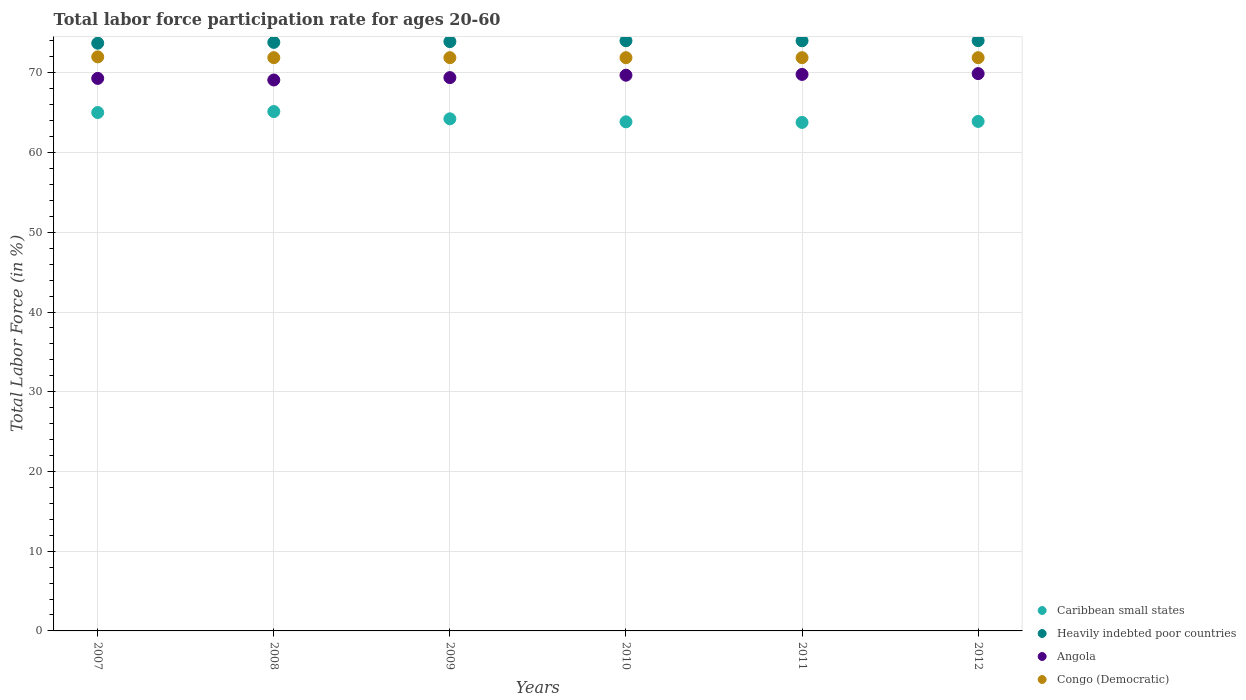How many different coloured dotlines are there?
Keep it short and to the point. 4. Is the number of dotlines equal to the number of legend labels?
Give a very brief answer. Yes. What is the labor force participation rate in Congo (Democratic) in 2011?
Provide a short and direct response. 71.9. Across all years, what is the maximum labor force participation rate in Heavily indebted poor countries?
Give a very brief answer. 74.03. Across all years, what is the minimum labor force participation rate in Congo (Democratic)?
Your response must be concise. 71.9. In which year was the labor force participation rate in Heavily indebted poor countries maximum?
Your response must be concise. 2012. What is the total labor force participation rate in Heavily indebted poor countries in the graph?
Offer a very short reply. 443.52. What is the difference between the labor force participation rate in Heavily indebted poor countries in 2010 and that in 2011?
Provide a short and direct response. 0.01. What is the difference between the labor force participation rate in Heavily indebted poor countries in 2007 and the labor force participation rate in Congo (Democratic) in 2010?
Keep it short and to the point. 1.82. What is the average labor force participation rate in Heavily indebted poor countries per year?
Your response must be concise. 73.92. In the year 2007, what is the difference between the labor force participation rate in Congo (Democratic) and labor force participation rate in Caribbean small states?
Provide a succinct answer. 6.98. What is the ratio of the labor force participation rate in Congo (Democratic) in 2011 to that in 2012?
Give a very brief answer. 1. Is the labor force participation rate in Congo (Democratic) in 2007 less than that in 2008?
Keep it short and to the point. No. What is the difference between the highest and the second highest labor force participation rate in Heavily indebted poor countries?
Offer a very short reply. 0.01. What is the difference between the highest and the lowest labor force participation rate in Heavily indebted poor countries?
Your answer should be compact. 0.32. In how many years, is the labor force participation rate in Caribbean small states greater than the average labor force participation rate in Caribbean small states taken over all years?
Offer a terse response. 2. Is it the case that in every year, the sum of the labor force participation rate in Congo (Democratic) and labor force participation rate in Caribbean small states  is greater than the sum of labor force participation rate in Heavily indebted poor countries and labor force participation rate in Angola?
Your response must be concise. Yes. Is it the case that in every year, the sum of the labor force participation rate in Caribbean small states and labor force participation rate in Heavily indebted poor countries  is greater than the labor force participation rate in Angola?
Keep it short and to the point. Yes. Is the labor force participation rate in Caribbean small states strictly greater than the labor force participation rate in Angola over the years?
Make the answer very short. No. How many years are there in the graph?
Your response must be concise. 6. Are the values on the major ticks of Y-axis written in scientific E-notation?
Keep it short and to the point. No. Does the graph contain any zero values?
Make the answer very short. No. Does the graph contain grids?
Offer a very short reply. Yes. How are the legend labels stacked?
Your answer should be very brief. Vertical. What is the title of the graph?
Offer a terse response. Total labor force participation rate for ages 20-60. Does "Lower middle income" appear as one of the legend labels in the graph?
Your response must be concise. No. What is the Total Labor Force (in %) in Caribbean small states in 2007?
Provide a succinct answer. 65.02. What is the Total Labor Force (in %) in Heavily indebted poor countries in 2007?
Provide a short and direct response. 73.72. What is the Total Labor Force (in %) in Angola in 2007?
Provide a short and direct response. 69.3. What is the Total Labor Force (in %) in Caribbean small states in 2008?
Keep it short and to the point. 65.14. What is the Total Labor Force (in %) of Heavily indebted poor countries in 2008?
Your answer should be compact. 73.82. What is the Total Labor Force (in %) of Angola in 2008?
Your answer should be compact. 69.1. What is the Total Labor Force (in %) of Congo (Democratic) in 2008?
Give a very brief answer. 71.9. What is the Total Labor Force (in %) of Caribbean small states in 2009?
Your response must be concise. 64.23. What is the Total Labor Force (in %) of Heavily indebted poor countries in 2009?
Provide a short and direct response. 73.92. What is the Total Labor Force (in %) in Angola in 2009?
Provide a succinct answer. 69.4. What is the Total Labor Force (in %) of Congo (Democratic) in 2009?
Your answer should be very brief. 71.9. What is the Total Labor Force (in %) of Caribbean small states in 2010?
Provide a short and direct response. 63.85. What is the Total Labor Force (in %) in Heavily indebted poor countries in 2010?
Provide a short and direct response. 74.02. What is the Total Labor Force (in %) of Angola in 2010?
Make the answer very short. 69.7. What is the Total Labor Force (in %) of Congo (Democratic) in 2010?
Provide a short and direct response. 71.9. What is the Total Labor Force (in %) of Caribbean small states in 2011?
Offer a terse response. 63.78. What is the Total Labor Force (in %) of Heavily indebted poor countries in 2011?
Provide a short and direct response. 74.02. What is the Total Labor Force (in %) of Angola in 2011?
Offer a very short reply. 69.8. What is the Total Labor Force (in %) in Congo (Democratic) in 2011?
Provide a succinct answer. 71.9. What is the Total Labor Force (in %) of Caribbean small states in 2012?
Your response must be concise. 63.9. What is the Total Labor Force (in %) of Heavily indebted poor countries in 2012?
Your answer should be very brief. 74.03. What is the Total Labor Force (in %) in Angola in 2012?
Give a very brief answer. 69.9. What is the Total Labor Force (in %) of Congo (Democratic) in 2012?
Give a very brief answer. 71.9. Across all years, what is the maximum Total Labor Force (in %) in Caribbean small states?
Your response must be concise. 65.14. Across all years, what is the maximum Total Labor Force (in %) of Heavily indebted poor countries?
Provide a short and direct response. 74.03. Across all years, what is the maximum Total Labor Force (in %) in Angola?
Provide a succinct answer. 69.9. Across all years, what is the minimum Total Labor Force (in %) in Caribbean small states?
Give a very brief answer. 63.78. Across all years, what is the minimum Total Labor Force (in %) in Heavily indebted poor countries?
Offer a very short reply. 73.72. Across all years, what is the minimum Total Labor Force (in %) in Angola?
Make the answer very short. 69.1. Across all years, what is the minimum Total Labor Force (in %) of Congo (Democratic)?
Keep it short and to the point. 71.9. What is the total Total Labor Force (in %) of Caribbean small states in the graph?
Offer a very short reply. 385.93. What is the total Total Labor Force (in %) of Heavily indebted poor countries in the graph?
Ensure brevity in your answer.  443.52. What is the total Total Labor Force (in %) in Angola in the graph?
Make the answer very short. 417.2. What is the total Total Labor Force (in %) in Congo (Democratic) in the graph?
Your answer should be compact. 431.5. What is the difference between the Total Labor Force (in %) in Caribbean small states in 2007 and that in 2008?
Your answer should be very brief. -0.12. What is the difference between the Total Labor Force (in %) in Heavily indebted poor countries in 2007 and that in 2008?
Keep it short and to the point. -0.1. What is the difference between the Total Labor Force (in %) in Congo (Democratic) in 2007 and that in 2008?
Provide a short and direct response. 0.1. What is the difference between the Total Labor Force (in %) in Caribbean small states in 2007 and that in 2009?
Provide a short and direct response. 0.79. What is the difference between the Total Labor Force (in %) of Heavily indebted poor countries in 2007 and that in 2009?
Your answer should be compact. -0.2. What is the difference between the Total Labor Force (in %) in Caribbean small states in 2007 and that in 2010?
Offer a terse response. 1.17. What is the difference between the Total Labor Force (in %) of Heavily indebted poor countries in 2007 and that in 2010?
Offer a terse response. -0.31. What is the difference between the Total Labor Force (in %) of Caribbean small states in 2007 and that in 2011?
Keep it short and to the point. 1.24. What is the difference between the Total Labor Force (in %) of Heavily indebted poor countries in 2007 and that in 2011?
Your response must be concise. -0.3. What is the difference between the Total Labor Force (in %) of Caribbean small states in 2007 and that in 2012?
Provide a succinct answer. 1.12. What is the difference between the Total Labor Force (in %) of Heavily indebted poor countries in 2007 and that in 2012?
Provide a succinct answer. -0.32. What is the difference between the Total Labor Force (in %) of Angola in 2007 and that in 2012?
Offer a very short reply. -0.6. What is the difference between the Total Labor Force (in %) of Congo (Democratic) in 2007 and that in 2012?
Ensure brevity in your answer.  0.1. What is the difference between the Total Labor Force (in %) in Caribbean small states in 2008 and that in 2009?
Give a very brief answer. 0.91. What is the difference between the Total Labor Force (in %) of Heavily indebted poor countries in 2008 and that in 2009?
Provide a succinct answer. -0.1. What is the difference between the Total Labor Force (in %) in Angola in 2008 and that in 2009?
Keep it short and to the point. -0.3. What is the difference between the Total Labor Force (in %) of Caribbean small states in 2008 and that in 2010?
Offer a terse response. 1.29. What is the difference between the Total Labor Force (in %) in Heavily indebted poor countries in 2008 and that in 2010?
Provide a succinct answer. -0.21. What is the difference between the Total Labor Force (in %) in Angola in 2008 and that in 2010?
Your answer should be compact. -0.6. What is the difference between the Total Labor Force (in %) of Caribbean small states in 2008 and that in 2011?
Give a very brief answer. 1.36. What is the difference between the Total Labor Force (in %) in Heavily indebted poor countries in 2008 and that in 2011?
Your answer should be very brief. -0.2. What is the difference between the Total Labor Force (in %) in Congo (Democratic) in 2008 and that in 2011?
Make the answer very short. 0. What is the difference between the Total Labor Force (in %) of Caribbean small states in 2008 and that in 2012?
Your answer should be very brief. 1.24. What is the difference between the Total Labor Force (in %) in Heavily indebted poor countries in 2008 and that in 2012?
Your answer should be compact. -0.22. What is the difference between the Total Labor Force (in %) in Congo (Democratic) in 2008 and that in 2012?
Offer a very short reply. 0. What is the difference between the Total Labor Force (in %) of Caribbean small states in 2009 and that in 2010?
Make the answer very short. 0.38. What is the difference between the Total Labor Force (in %) in Heavily indebted poor countries in 2009 and that in 2010?
Offer a terse response. -0.11. What is the difference between the Total Labor Force (in %) in Caribbean small states in 2009 and that in 2011?
Make the answer very short. 0.45. What is the difference between the Total Labor Force (in %) in Heavily indebted poor countries in 2009 and that in 2011?
Your response must be concise. -0.1. What is the difference between the Total Labor Force (in %) of Caribbean small states in 2009 and that in 2012?
Offer a terse response. 0.33. What is the difference between the Total Labor Force (in %) of Heavily indebted poor countries in 2009 and that in 2012?
Ensure brevity in your answer.  -0.12. What is the difference between the Total Labor Force (in %) in Angola in 2009 and that in 2012?
Make the answer very short. -0.5. What is the difference between the Total Labor Force (in %) of Caribbean small states in 2010 and that in 2011?
Keep it short and to the point. 0.07. What is the difference between the Total Labor Force (in %) of Heavily indebted poor countries in 2010 and that in 2011?
Give a very brief answer. 0.01. What is the difference between the Total Labor Force (in %) in Angola in 2010 and that in 2011?
Provide a short and direct response. -0.1. What is the difference between the Total Labor Force (in %) in Caribbean small states in 2010 and that in 2012?
Provide a short and direct response. -0.05. What is the difference between the Total Labor Force (in %) of Heavily indebted poor countries in 2010 and that in 2012?
Ensure brevity in your answer.  -0.01. What is the difference between the Total Labor Force (in %) of Angola in 2010 and that in 2012?
Offer a very short reply. -0.2. What is the difference between the Total Labor Force (in %) of Caribbean small states in 2011 and that in 2012?
Provide a succinct answer. -0.12. What is the difference between the Total Labor Force (in %) of Heavily indebted poor countries in 2011 and that in 2012?
Keep it short and to the point. -0.02. What is the difference between the Total Labor Force (in %) of Caribbean small states in 2007 and the Total Labor Force (in %) of Heavily indebted poor countries in 2008?
Provide a short and direct response. -8.8. What is the difference between the Total Labor Force (in %) in Caribbean small states in 2007 and the Total Labor Force (in %) in Angola in 2008?
Offer a terse response. -4.08. What is the difference between the Total Labor Force (in %) of Caribbean small states in 2007 and the Total Labor Force (in %) of Congo (Democratic) in 2008?
Your answer should be compact. -6.88. What is the difference between the Total Labor Force (in %) of Heavily indebted poor countries in 2007 and the Total Labor Force (in %) of Angola in 2008?
Provide a succinct answer. 4.62. What is the difference between the Total Labor Force (in %) of Heavily indebted poor countries in 2007 and the Total Labor Force (in %) of Congo (Democratic) in 2008?
Your answer should be very brief. 1.82. What is the difference between the Total Labor Force (in %) in Caribbean small states in 2007 and the Total Labor Force (in %) in Heavily indebted poor countries in 2009?
Give a very brief answer. -8.9. What is the difference between the Total Labor Force (in %) in Caribbean small states in 2007 and the Total Labor Force (in %) in Angola in 2009?
Keep it short and to the point. -4.38. What is the difference between the Total Labor Force (in %) of Caribbean small states in 2007 and the Total Labor Force (in %) of Congo (Democratic) in 2009?
Ensure brevity in your answer.  -6.88. What is the difference between the Total Labor Force (in %) of Heavily indebted poor countries in 2007 and the Total Labor Force (in %) of Angola in 2009?
Offer a very short reply. 4.32. What is the difference between the Total Labor Force (in %) of Heavily indebted poor countries in 2007 and the Total Labor Force (in %) of Congo (Democratic) in 2009?
Your answer should be compact. 1.82. What is the difference between the Total Labor Force (in %) of Caribbean small states in 2007 and the Total Labor Force (in %) of Heavily indebted poor countries in 2010?
Make the answer very short. -9. What is the difference between the Total Labor Force (in %) in Caribbean small states in 2007 and the Total Labor Force (in %) in Angola in 2010?
Keep it short and to the point. -4.68. What is the difference between the Total Labor Force (in %) in Caribbean small states in 2007 and the Total Labor Force (in %) in Congo (Democratic) in 2010?
Your response must be concise. -6.88. What is the difference between the Total Labor Force (in %) in Heavily indebted poor countries in 2007 and the Total Labor Force (in %) in Angola in 2010?
Your answer should be compact. 4.02. What is the difference between the Total Labor Force (in %) of Heavily indebted poor countries in 2007 and the Total Labor Force (in %) of Congo (Democratic) in 2010?
Give a very brief answer. 1.82. What is the difference between the Total Labor Force (in %) of Angola in 2007 and the Total Labor Force (in %) of Congo (Democratic) in 2010?
Give a very brief answer. -2.6. What is the difference between the Total Labor Force (in %) of Caribbean small states in 2007 and the Total Labor Force (in %) of Heavily indebted poor countries in 2011?
Your answer should be very brief. -9. What is the difference between the Total Labor Force (in %) in Caribbean small states in 2007 and the Total Labor Force (in %) in Angola in 2011?
Your answer should be very brief. -4.78. What is the difference between the Total Labor Force (in %) in Caribbean small states in 2007 and the Total Labor Force (in %) in Congo (Democratic) in 2011?
Offer a terse response. -6.88. What is the difference between the Total Labor Force (in %) of Heavily indebted poor countries in 2007 and the Total Labor Force (in %) of Angola in 2011?
Ensure brevity in your answer.  3.92. What is the difference between the Total Labor Force (in %) in Heavily indebted poor countries in 2007 and the Total Labor Force (in %) in Congo (Democratic) in 2011?
Your response must be concise. 1.82. What is the difference between the Total Labor Force (in %) in Angola in 2007 and the Total Labor Force (in %) in Congo (Democratic) in 2011?
Offer a terse response. -2.6. What is the difference between the Total Labor Force (in %) in Caribbean small states in 2007 and the Total Labor Force (in %) in Heavily indebted poor countries in 2012?
Your answer should be compact. -9.01. What is the difference between the Total Labor Force (in %) of Caribbean small states in 2007 and the Total Labor Force (in %) of Angola in 2012?
Provide a short and direct response. -4.88. What is the difference between the Total Labor Force (in %) of Caribbean small states in 2007 and the Total Labor Force (in %) of Congo (Democratic) in 2012?
Offer a very short reply. -6.88. What is the difference between the Total Labor Force (in %) in Heavily indebted poor countries in 2007 and the Total Labor Force (in %) in Angola in 2012?
Give a very brief answer. 3.82. What is the difference between the Total Labor Force (in %) in Heavily indebted poor countries in 2007 and the Total Labor Force (in %) in Congo (Democratic) in 2012?
Keep it short and to the point. 1.82. What is the difference between the Total Labor Force (in %) in Angola in 2007 and the Total Labor Force (in %) in Congo (Democratic) in 2012?
Provide a short and direct response. -2.6. What is the difference between the Total Labor Force (in %) of Caribbean small states in 2008 and the Total Labor Force (in %) of Heavily indebted poor countries in 2009?
Give a very brief answer. -8.77. What is the difference between the Total Labor Force (in %) in Caribbean small states in 2008 and the Total Labor Force (in %) in Angola in 2009?
Your answer should be very brief. -4.26. What is the difference between the Total Labor Force (in %) in Caribbean small states in 2008 and the Total Labor Force (in %) in Congo (Democratic) in 2009?
Give a very brief answer. -6.76. What is the difference between the Total Labor Force (in %) in Heavily indebted poor countries in 2008 and the Total Labor Force (in %) in Angola in 2009?
Provide a short and direct response. 4.42. What is the difference between the Total Labor Force (in %) in Heavily indebted poor countries in 2008 and the Total Labor Force (in %) in Congo (Democratic) in 2009?
Provide a succinct answer. 1.92. What is the difference between the Total Labor Force (in %) in Angola in 2008 and the Total Labor Force (in %) in Congo (Democratic) in 2009?
Your answer should be very brief. -2.8. What is the difference between the Total Labor Force (in %) of Caribbean small states in 2008 and the Total Labor Force (in %) of Heavily indebted poor countries in 2010?
Provide a short and direct response. -8.88. What is the difference between the Total Labor Force (in %) of Caribbean small states in 2008 and the Total Labor Force (in %) of Angola in 2010?
Provide a succinct answer. -4.56. What is the difference between the Total Labor Force (in %) of Caribbean small states in 2008 and the Total Labor Force (in %) of Congo (Democratic) in 2010?
Your answer should be compact. -6.76. What is the difference between the Total Labor Force (in %) of Heavily indebted poor countries in 2008 and the Total Labor Force (in %) of Angola in 2010?
Your response must be concise. 4.12. What is the difference between the Total Labor Force (in %) in Heavily indebted poor countries in 2008 and the Total Labor Force (in %) in Congo (Democratic) in 2010?
Give a very brief answer. 1.92. What is the difference between the Total Labor Force (in %) in Angola in 2008 and the Total Labor Force (in %) in Congo (Democratic) in 2010?
Provide a succinct answer. -2.8. What is the difference between the Total Labor Force (in %) of Caribbean small states in 2008 and the Total Labor Force (in %) of Heavily indebted poor countries in 2011?
Your response must be concise. -8.87. What is the difference between the Total Labor Force (in %) in Caribbean small states in 2008 and the Total Labor Force (in %) in Angola in 2011?
Your answer should be compact. -4.66. What is the difference between the Total Labor Force (in %) of Caribbean small states in 2008 and the Total Labor Force (in %) of Congo (Democratic) in 2011?
Offer a terse response. -6.76. What is the difference between the Total Labor Force (in %) of Heavily indebted poor countries in 2008 and the Total Labor Force (in %) of Angola in 2011?
Ensure brevity in your answer.  4.02. What is the difference between the Total Labor Force (in %) in Heavily indebted poor countries in 2008 and the Total Labor Force (in %) in Congo (Democratic) in 2011?
Ensure brevity in your answer.  1.92. What is the difference between the Total Labor Force (in %) of Caribbean small states in 2008 and the Total Labor Force (in %) of Heavily indebted poor countries in 2012?
Provide a succinct answer. -8.89. What is the difference between the Total Labor Force (in %) in Caribbean small states in 2008 and the Total Labor Force (in %) in Angola in 2012?
Your answer should be very brief. -4.76. What is the difference between the Total Labor Force (in %) in Caribbean small states in 2008 and the Total Labor Force (in %) in Congo (Democratic) in 2012?
Your answer should be very brief. -6.76. What is the difference between the Total Labor Force (in %) of Heavily indebted poor countries in 2008 and the Total Labor Force (in %) of Angola in 2012?
Offer a very short reply. 3.92. What is the difference between the Total Labor Force (in %) of Heavily indebted poor countries in 2008 and the Total Labor Force (in %) of Congo (Democratic) in 2012?
Your response must be concise. 1.92. What is the difference between the Total Labor Force (in %) in Angola in 2008 and the Total Labor Force (in %) in Congo (Democratic) in 2012?
Your answer should be very brief. -2.8. What is the difference between the Total Labor Force (in %) of Caribbean small states in 2009 and the Total Labor Force (in %) of Heavily indebted poor countries in 2010?
Provide a succinct answer. -9.79. What is the difference between the Total Labor Force (in %) in Caribbean small states in 2009 and the Total Labor Force (in %) in Angola in 2010?
Offer a very short reply. -5.47. What is the difference between the Total Labor Force (in %) in Caribbean small states in 2009 and the Total Labor Force (in %) in Congo (Democratic) in 2010?
Give a very brief answer. -7.67. What is the difference between the Total Labor Force (in %) in Heavily indebted poor countries in 2009 and the Total Labor Force (in %) in Angola in 2010?
Provide a succinct answer. 4.22. What is the difference between the Total Labor Force (in %) of Heavily indebted poor countries in 2009 and the Total Labor Force (in %) of Congo (Democratic) in 2010?
Your answer should be compact. 2.02. What is the difference between the Total Labor Force (in %) of Caribbean small states in 2009 and the Total Labor Force (in %) of Heavily indebted poor countries in 2011?
Offer a terse response. -9.79. What is the difference between the Total Labor Force (in %) in Caribbean small states in 2009 and the Total Labor Force (in %) in Angola in 2011?
Your response must be concise. -5.57. What is the difference between the Total Labor Force (in %) in Caribbean small states in 2009 and the Total Labor Force (in %) in Congo (Democratic) in 2011?
Keep it short and to the point. -7.67. What is the difference between the Total Labor Force (in %) of Heavily indebted poor countries in 2009 and the Total Labor Force (in %) of Angola in 2011?
Give a very brief answer. 4.12. What is the difference between the Total Labor Force (in %) of Heavily indebted poor countries in 2009 and the Total Labor Force (in %) of Congo (Democratic) in 2011?
Provide a short and direct response. 2.02. What is the difference between the Total Labor Force (in %) in Angola in 2009 and the Total Labor Force (in %) in Congo (Democratic) in 2011?
Offer a terse response. -2.5. What is the difference between the Total Labor Force (in %) in Caribbean small states in 2009 and the Total Labor Force (in %) in Heavily indebted poor countries in 2012?
Your answer should be very brief. -9.8. What is the difference between the Total Labor Force (in %) in Caribbean small states in 2009 and the Total Labor Force (in %) in Angola in 2012?
Give a very brief answer. -5.67. What is the difference between the Total Labor Force (in %) of Caribbean small states in 2009 and the Total Labor Force (in %) of Congo (Democratic) in 2012?
Give a very brief answer. -7.67. What is the difference between the Total Labor Force (in %) of Heavily indebted poor countries in 2009 and the Total Labor Force (in %) of Angola in 2012?
Provide a short and direct response. 4.02. What is the difference between the Total Labor Force (in %) in Heavily indebted poor countries in 2009 and the Total Labor Force (in %) in Congo (Democratic) in 2012?
Give a very brief answer. 2.02. What is the difference between the Total Labor Force (in %) in Angola in 2009 and the Total Labor Force (in %) in Congo (Democratic) in 2012?
Offer a terse response. -2.5. What is the difference between the Total Labor Force (in %) of Caribbean small states in 2010 and the Total Labor Force (in %) of Heavily indebted poor countries in 2011?
Your response must be concise. -10.16. What is the difference between the Total Labor Force (in %) of Caribbean small states in 2010 and the Total Labor Force (in %) of Angola in 2011?
Keep it short and to the point. -5.95. What is the difference between the Total Labor Force (in %) of Caribbean small states in 2010 and the Total Labor Force (in %) of Congo (Democratic) in 2011?
Your answer should be very brief. -8.05. What is the difference between the Total Labor Force (in %) of Heavily indebted poor countries in 2010 and the Total Labor Force (in %) of Angola in 2011?
Your answer should be very brief. 4.22. What is the difference between the Total Labor Force (in %) in Heavily indebted poor countries in 2010 and the Total Labor Force (in %) in Congo (Democratic) in 2011?
Provide a short and direct response. 2.12. What is the difference between the Total Labor Force (in %) of Angola in 2010 and the Total Labor Force (in %) of Congo (Democratic) in 2011?
Make the answer very short. -2.2. What is the difference between the Total Labor Force (in %) in Caribbean small states in 2010 and the Total Labor Force (in %) in Heavily indebted poor countries in 2012?
Give a very brief answer. -10.18. What is the difference between the Total Labor Force (in %) of Caribbean small states in 2010 and the Total Labor Force (in %) of Angola in 2012?
Your answer should be compact. -6.05. What is the difference between the Total Labor Force (in %) in Caribbean small states in 2010 and the Total Labor Force (in %) in Congo (Democratic) in 2012?
Offer a very short reply. -8.05. What is the difference between the Total Labor Force (in %) of Heavily indebted poor countries in 2010 and the Total Labor Force (in %) of Angola in 2012?
Your answer should be compact. 4.12. What is the difference between the Total Labor Force (in %) in Heavily indebted poor countries in 2010 and the Total Labor Force (in %) in Congo (Democratic) in 2012?
Give a very brief answer. 2.12. What is the difference between the Total Labor Force (in %) of Caribbean small states in 2011 and the Total Labor Force (in %) of Heavily indebted poor countries in 2012?
Keep it short and to the point. -10.25. What is the difference between the Total Labor Force (in %) of Caribbean small states in 2011 and the Total Labor Force (in %) of Angola in 2012?
Provide a short and direct response. -6.12. What is the difference between the Total Labor Force (in %) in Caribbean small states in 2011 and the Total Labor Force (in %) in Congo (Democratic) in 2012?
Give a very brief answer. -8.12. What is the difference between the Total Labor Force (in %) in Heavily indebted poor countries in 2011 and the Total Labor Force (in %) in Angola in 2012?
Offer a very short reply. 4.12. What is the difference between the Total Labor Force (in %) in Heavily indebted poor countries in 2011 and the Total Labor Force (in %) in Congo (Democratic) in 2012?
Offer a very short reply. 2.12. What is the average Total Labor Force (in %) in Caribbean small states per year?
Your answer should be compact. 64.32. What is the average Total Labor Force (in %) in Heavily indebted poor countries per year?
Ensure brevity in your answer.  73.92. What is the average Total Labor Force (in %) of Angola per year?
Your answer should be very brief. 69.53. What is the average Total Labor Force (in %) of Congo (Democratic) per year?
Offer a very short reply. 71.92. In the year 2007, what is the difference between the Total Labor Force (in %) in Caribbean small states and Total Labor Force (in %) in Heavily indebted poor countries?
Provide a short and direct response. -8.7. In the year 2007, what is the difference between the Total Labor Force (in %) of Caribbean small states and Total Labor Force (in %) of Angola?
Ensure brevity in your answer.  -4.28. In the year 2007, what is the difference between the Total Labor Force (in %) in Caribbean small states and Total Labor Force (in %) in Congo (Democratic)?
Your answer should be compact. -6.98. In the year 2007, what is the difference between the Total Labor Force (in %) of Heavily indebted poor countries and Total Labor Force (in %) of Angola?
Provide a short and direct response. 4.42. In the year 2007, what is the difference between the Total Labor Force (in %) of Heavily indebted poor countries and Total Labor Force (in %) of Congo (Democratic)?
Offer a terse response. 1.72. In the year 2007, what is the difference between the Total Labor Force (in %) of Angola and Total Labor Force (in %) of Congo (Democratic)?
Your answer should be very brief. -2.7. In the year 2008, what is the difference between the Total Labor Force (in %) of Caribbean small states and Total Labor Force (in %) of Heavily indebted poor countries?
Provide a short and direct response. -8.67. In the year 2008, what is the difference between the Total Labor Force (in %) of Caribbean small states and Total Labor Force (in %) of Angola?
Offer a terse response. -3.96. In the year 2008, what is the difference between the Total Labor Force (in %) of Caribbean small states and Total Labor Force (in %) of Congo (Democratic)?
Offer a very short reply. -6.76. In the year 2008, what is the difference between the Total Labor Force (in %) in Heavily indebted poor countries and Total Labor Force (in %) in Angola?
Offer a very short reply. 4.72. In the year 2008, what is the difference between the Total Labor Force (in %) in Heavily indebted poor countries and Total Labor Force (in %) in Congo (Democratic)?
Offer a terse response. 1.92. In the year 2009, what is the difference between the Total Labor Force (in %) of Caribbean small states and Total Labor Force (in %) of Heavily indebted poor countries?
Offer a very short reply. -9.68. In the year 2009, what is the difference between the Total Labor Force (in %) in Caribbean small states and Total Labor Force (in %) in Angola?
Make the answer very short. -5.17. In the year 2009, what is the difference between the Total Labor Force (in %) of Caribbean small states and Total Labor Force (in %) of Congo (Democratic)?
Offer a very short reply. -7.67. In the year 2009, what is the difference between the Total Labor Force (in %) in Heavily indebted poor countries and Total Labor Force (in %) in Angola?
Ensure brevity in your answer.  4.52. In the year 2009, what is the difference between the Total Labor Force (in %) in Heavily indebted poor countries and Total Labor Force (in %) in Congo (Democratic)?
Your answer should be compact. 2.02. In the year 2009, what is the difference between the Total Labor Force (in %) in Angola and Total Labor Force (in %) in Congo (Democratic)?
Make the answer very short. -2.5. In the year 2010, what is the difference between the Total Labor Force (in %) of Caribbean small states and Total Labor Force (in %) of Heavily indebted poor countries?
Provide a succinct answer. -10.17. In the year 2010, what is the difference between the Total Labor Force (in %) in Caribbean small states and Total Labor Force (in %) in Angola?
Your response must be concise. -5.85. In the year 2010, what is the difference between the Total Labor Force (in %) of Caribbean small states and Total Labor Force (in %) of Congo (Democratic)?
Give a very brief answer. -8.05. In the year 2010, what is the difference between the Total Labor Force (in %) of Heavily indebted poor countries and Total Labor Force (in %) of Angola?
Your answer should be compact. 4.32. In the year 2010, what is the difference between the Total Labor Force (in %) in Heavily indebted poor countries and Total Labor Force (in %) in Congo (Democratic)?
Ensure brevity in your answer.  2.12. In the year 2011, what is the difference between the Total Labor Force (in %) in Caribbean small states and Total Labor Force (in %) in Heavily indebted poor countries?
Your answer should be very brief. -10.24. In the year 2011, what is the difference between the Total Labor Force (in %) of Caribbean small states and Total Labor Force (in %) of Angola?
Your answer should be very brief. -6.02. In the year 2011, what is the difference between the Total Labor Force (in %) in Caribbean small states and Total Labor Force (in %) in Congo (Democratic)?
Ensure brevity in your answer.  -8.12. In the year 2011, what is the difference between the Total Labor Force (in %) of Heavily indebted poor countries and Total Labor Force (in %) of Angola?
Your answer should be compact. 4.22. In the year 2011, what is the difference between the Total Labor Force (in %) of Heavily indebted poor countries and Total Labor Force (in %) of Congo (Democratic)?
Ensure brevity in your answer.  2.12. In the year 2011, what is the difference between the Total Labor Force (in %) in Angola and Total Labor Force (in %) in Congo (Democratic)?
Provide a succinct answer. -2.1. In the year 2012, what is the difference between the Total Labor Force (in %) of Caribbean small states and Total Labor Force (in %) of Heavily indebted poor countries?
Ensure brevity in your answer.  -10.13. In the year 2012, what is the difference between the Total Labor Force (in %) of Caribbean small states and Total Labor Force (in %) of Angola?
Offer a terse response. -6. In the year 2012, what is the difference between the Total Labor Force (in %) in Caribbean small states and Total Labor Force (in %) in Congo (Democratic)?
Offer a terse response. -8. In the year 2012, what is the difference between the Total Labor Force (in %) of Heavily indebted poor countries and Total Labor Force (in %) of Angola?
Your answer should be compact. 4.13. In the year 2012, what is the difference between the Total Labor Force (in %) in Heavily indebted poor countries and Total Labor Force (in %) in Congo (Democratic)?
Ensure brevity in your answer.  2.13. What is the ratio of the Total Labor Force (in %) in Caribbean small states in 2007 to that in 2008?
Ensure brevity in your answer.  1. What is the ratio of the Total Labor Force (in %) in Congo (Democratic) in 2007 to that in 2008?
Give a very brief answer. 1. What is the ratio of the Total Labor Force (in %) in Caribbean small states in 2007 to that in 2009?
Your response must be concise. 1.01. What is the ratio of the Total Labor Force (in %) in Heavily indebted poor countries in 2007 to that in 2009?
Make the answer very short. 1. What is the ratio of the Total Labor Force (in %) in Angola in 2007 to that in 2009?
Keep it short and to the point. 1. What is the ratio of the Total Labor Force (in %) of Caribbean small states in 2007 to that in 2010?
Make the answer very short. 1.02. What is the ratio of the Total Labor Force (in %) in Angola in 2007 to that in 2010?
Offer a very short reply. 0.99. What is the ratio of the Total Labor Force (in %) in Congo (Democratic) in 2007 to that in 2010?
Your answer should be very brief. 1. What is the ratio of the Total Labor Force (in %) of Caribbean small states in 2007 to that in 2011?
Provide a succinct answer. 1.02. What is the ratio of the Total Labor Force (in %) in Heavily indebted poor countries in 2007 to that in 2011?
Provide a succinct answer. 1. What is the ratio of the Total Labor Force (in %) of Angola in 2007 to that in 2011?
Provide a short and direct response. 0.99. What is the ratio of the Total Labor Force (in %) of Congo (Democratic) in 2007 to that in 2011?
Make the answer very short. 1. What is the ratio of the Total Labor Force (in %) in Caribbean small states in 2007 to that in 2012?
Your response must be concise. 1.02. What is the ratio of the Total Labor Force (in %) of Heavily indebted poor countries in 2007 to that in 2012?
Provide a short and direct response. 1. What is the ratio of the Total Labor Force (in %) in Caribbean small states in 2008 to that in 2009?
Provide a succinct answer. 1.01. What is the ratio of the Total Labor Force (in %) of Caribbean small states in 2008 to that in 2010?
Your response must be concise. 1.02. What is the ratio of the Total Labor Force (in %) of Caribbean small states in 2008 to that in 2011?
Your response must be concise. 1.02. What is the ratio of the Total Labor Force (in %) in Heavily indebted poor countries in 2008 to that in 2011?
Provide a short and direct response. 1. What is the ratio of the Total Labor Force (in %) of Angola in 2008 to that in 2011?
Give a very brief answer. 0.99. What is the ratio of the Total Labor Force (in %) of Caribbean small states in 2008 to that in 2012?
Your answer should be compact. 1.02. What is the ratio of the Total Labor Force (in %) of Heavily indebted poor countries in 2008 to that in 2012?
Provide a short and direct response. 1. What is the ratio of the Total Labor Force (in %) of Angola in 2008 to that in 2012?
Make the answer very short. 0.99. What is the ratio of the Total Labor Force (in %) of Caribbean small states in 2009 to that in 2010?
Your answer should be compact. 1.01. What is the ratio of the Total Labor Force (in %) in Heavily indebted poor countries in 2009 to that in 2010?
Provide a short and direct response. 1. What is the ratio of the Total Labor Force (in %) of Angola in 2009 to that in 2010?
Ensure brevity in your answer.  1. What is the ratio of the Total Labor Force (in %) of Congo (Democratic) in 2009 to that in 2010?
Make the answer very short. 1. What is the ratio of the Total Labor Force (in %) in Caribbean small states in 2009 to that in 2011?
Provide a succinct answer. 1.01. What is the ratio of the Total Labor Force (in %) of Heavily indebted poor countries in 2009 to that in 2011?
Your answer should be compact. 1. What is the ratio of the Total Labor Force (in %) in Heavily indebted poor countries in 2009 to that in 2012?
Provide a succinct answer. 1. What is the ratio of the Total Labor Force (in %) of Angola in 2010 to that in 2011?
Give a very brief answer. 1. What is the ratio of the Total Labor Force (in %) in Congo (Democratic) in 2010 to that in 2011?
Your answer should be compact. 1. What is the ratio of the Total Labor Force (in %) of Caribbean small states in 2010 to that in 2012?
Provide a short and direct response. 1. What is the ratio of the Total Labor Force (in %) of Angola in 2010 to that in 2012?
Offer a terse response. 1. What is the ratio of the Total Labor Force (in %) of Congo (Democratic) in 2010 to that in 2012?
Provide a succinct answer. 1. What is the ratio of the Total Labor Force (in %) in Caribbean small states in 2011 to that in 2012?
Give a very brief answer. 1. What is the ratio of the Total Labor Force (in %) of Heavily indebted poor countries in 2011 to that in 2012?
Give a very brief answer. 1. What is the ratio of the Total Labor Force (in %) of Angola in 2011 to that in 2012?
Your answer should be compact. 1. What is the ratio of the Total Labor Force (in %) of Congo (Democratic) in 2011 to that in 2012?
Keep it short and to the point. 1. What is the difference between the highest and the second highest Total Labor Force (in %) of Caribbean small states?
Make the answer very short. 0.12. What is the difference between the highest and the second highest Total Labor Force (in %) in Heavily indebted poor countries?
Ensure brevity in your answer.  0.01. What is the difference between the highest and the second highest Total Labor Force (in %) of Angola?
Make the answer very short. 0.1. What is the difference between the highest and the second highest Total Labor Force (in %) in Congo (Democratic)?
Your answer should be very brief. 0.1. What is the difference between the highest and the lowest Total Labor Force (in %) in Caribbean small states?
Provide a short and direct response. 1.36. What is the difference between the highest and the lowest Total Labor Force (in %) in Heavily indebted poor countries?
Provide a short and direct response. 0.32. What is the difference between the highest and the lowest Total Labor Force (in %) in Angola?
Provide a succinct answer. 0.8. What is the difference between the highest and the lowest Total Labor Force (in %) of Congo (Democratic)?
Your response must be concise. 0.1. 